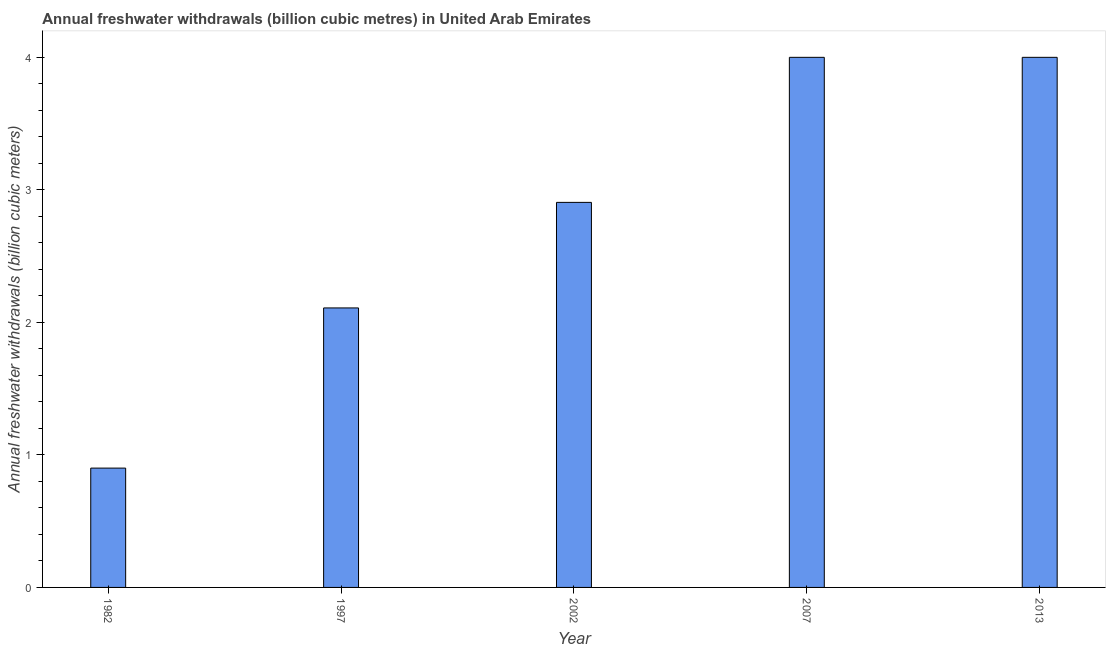Does the graph contain any zero values?
Keep it short and to the point. No. What is the title of the graph?
Offer a terse response. Annual freshwater withdrawals (billion cubic metres) in United Arab Emirates. What is the label or title of the Y-axis?
Keep it short and to the point. Annual freshwater withdrawals (billion cubic meters). What is the annual freshwater withdrawals in 1982?
Give a very brief answer. 0.9. Across all years, what is the maximum annual freshwater withdrawals?
Give a very brief answer. 4. Across all years, what is the minimum annual freshwater withdrawals?
Offer a terse response. 0.9. In which year was the annual freshwater withdrawals maximum?
Your answer should be very brief. 2007. What is the sum of the annual freshwater withdrawals?
Ensure brevity in your answer.  13.91. What is the difference between the annual freshwater withdrawals in 1997 and 2013?
Provide a succinct answer. -1.89. What is the average annual freshwater withdrawals per year?
Give a very brief answer. 2.78. What is the median annual freshwater withdrawals?
Your answer should be very brief. 2.9. In how many years, is the annual freshwater withdrawals greater than 2.2 billion cubic meters?
Provide a short and direct response. 3. What is the ratio of the annual freshwater withdrawals in 1982 to that in 1997?
Your answer should be compact. 0.43. Is the annual freshwater withdrawals in 1982 less than that in 1997?
Give a very brief answer. Yes. Is the sum of the annual freshwater withdrawals in 1982 and 2007 greater than the maximum annual freshwater withdrawals across all years?
Provide a short and direct response. Yes. What is the difference between the highest and the lowest annual freshwater withdrawals?
Provide a short and direct response. 3.1. How many bars are there?
Ensure brevity in your answer.  5. How many years are there in the graph?
Provide a short and direct response. 5. What is the difference between two consecutive major ticks on the Y-axis?
Your response must be concise. 1. What is the Annual freshwater withdrawals (billion cubic meters) in 1997?
Your answer should be compact. 2.11. What is the Annual freshwater withdrawals (billion cubic meters) in 2002?
Your answer should be very brief. 2.9. What is the Annual freshwater withdrawals (billion cubic meters) of 2007?
Make the answer very short. 4. What is the Annual freshwater withdrawals (billion cubic meters) in 2013?
Make the answer very short. 4. What is the difference between the Annual freshwater withdrawals (billion cubic meters) in 1982 and 1997?
Provide a succinct answer. -1.21. What is the difference between the Annual freshwater withdrawals (billion cubic meters) in 1982 and 2002?
Your answer should be compact. -2. What is the difference between the Annual freshwater withdrawals (billion cubic meters) in 1982 and 2007?
Provide a short and direct response. -3.1. What is the difference between the Annual freshwater withdrawals (billion cubic meters) in 1982 and 2013?
Keep it short and to the point. -3.1. What is the difference between the Annual freshwater withdrawals (billion cubic meters) in 1997 and 2002?
Provide a short and direct response. -0.8. What is the difference between the Annual freshwater withdrawals (billion cubic meters) in 1997 and 2007?
Make the answer very short. -1.89. What is the difference between the Annual freshwater withdrawals (billion cubic meters) in 1997 and 2013?
Give a very brief answer. -1.89. What is the difference between the Annual freshwater withdrawals (billion cubic meters) in 2002 and 2007?
Give a very brief answer. -1.09. What is the difference between the Annual freshwater withdrawals (billion cubic meters) in 2002 and 2013?
Ensure brevity in your answer.  -1.09. What is the difference between the Annual freshwater withdrawals (billion cubic meters) in 2007 and 2013?
Make the answer very short. 0. What is the ratio of the Annual freshwater withdrawals (billion cubic meters) in 1982 to that in 1997?
Your answer should be very brief. 0.43. What is the ratio of the Annual freshwater withdrawals (billion cubic meters) in 1982 to that in 2002?
Provide a short and direct response. 0.31. What is the ratio of the Annual freshwater withdrawals (billion cubic meters) in 1982 to that in 2007?
Your answer should be compact. 0.23. What is the ratio of the Annual freshwater withdrawals (billion cubic meters) in 1982 to that in 2013?
Provide a succinct answer. 0.23. What is the ratio of the Annual freshwater withdrawals (billion cubic meters) in 1997 to that in 2002?
Your answer should be compact. 0.73. What is the ratio of the Annual freshwater withdrawals (billion cubic meters) in 1997 to that in 2007?
Your answer should be very brief. 0.53. What is the ratio of the Annual freshwater withdrawals (billion cubic meters) in 1997 to that in 2013?
Keep it short and to the point. 0.53. What is the ratio of the Annual freshwater withdrawals (billion cubic meters) in 2002 to that in 2007?
Keep it short and to the point. 0.73. What is the ratio of the Annual freshwater withdrawals (billion cubic meters) in 2002 to that in 2013?
Offer a very short reply. 0.73. What is the ratio of the Annual freshwater withdrawals (billion cubic meters) in 2007 to that in 2013?
Provide a succinct answer. 1. 